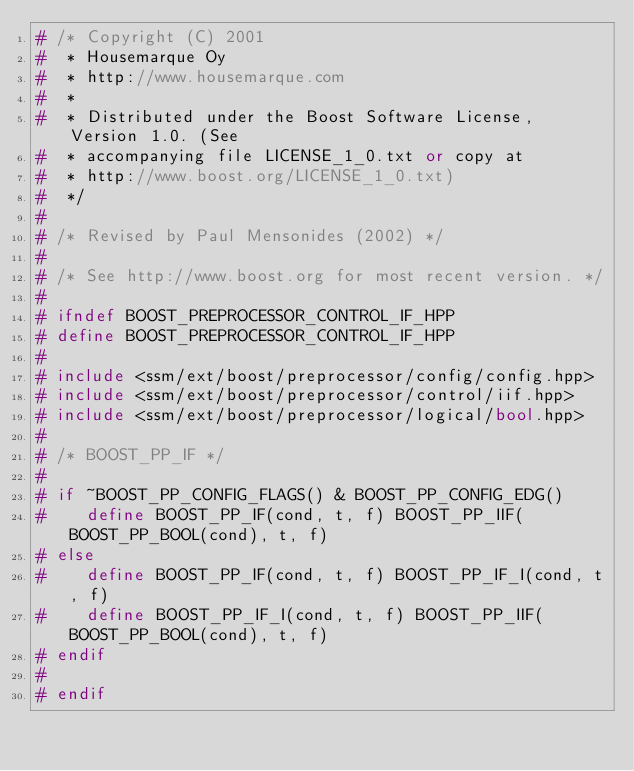Convert code to text. <code><loc_0><loc_0><loc_500><loc_500><_C++_># /* Copyright (C) 2001
#  * Housemarque Oy
#  * http://www.housemarque.com
#  *
#  * Distributed under the Boost Software License, Version 1.0. (See
#  * accompanying file LICENSE_1_0.txt or copy at
#  * http://www.boost.org/LICENSE_1_0.txt)
#  */
#
# /* Revised by Paul Mensonides (2002) */
#
# /* See http://www.boost.org for most recent version. */
#
# ifndef BOOST_PREPROCESSOR_CONTROL_IF_HPP
# define BOOST_PREPROCESSOR_CONTROL_IF_HPP
#
# include <ssm/ext/boost/preprocessor/config/config.hpp>
# include <ssm/ext/boost/preprocessor/control/iif.hpp>
# include <ssm/ext/boost/preprocessor/logical/bool.hpp>
#
# /* BOOST_PP_IF */
#
# if ~BOOST_PP_CONFIG_FLAGS() & BOOST_PP_CONFIG_EDG()
#    define BOOST_PP_IF(cond, t, f) BOOST_PP_IIF(BOOST_PP_BOOL(cond), t, f)
# else
#    define BOOST_PP_IF(cond, t, f) BOOST_PP_IF_I(cond, t, f)
#    define BOOST_PP_IF_I(cond, t, f) BOOST_PP_IIF(BOOST_PP_BOOL(cond), t, f)
# endif
#
# endif
</code> 